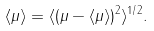Convert formula to latex. <formula><loc_0><loc_0><loc_500><loc_500>\langle \mu \rangle = \langle ( \mu - \langle \mu \rangle ) ^ { 2 } \rangle ^ { 1 / 2 } .</formula> 